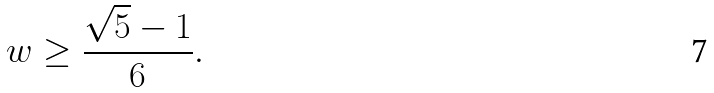Convert formula to latex. <formula><loc_0><loc_0><loc_500><loc_500>w \geq \frac { \sqrt { 5 } - 1 } { 6 } .</formula> 